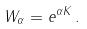Convert formula to latex. <formula><loc_0><loc_0><loc_500><loc_500>W _ { \alpha } = e ^ { \alpha K } \, .</formula> 